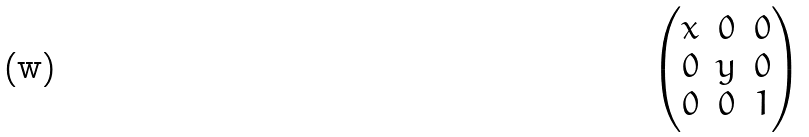<formula> <loc_0><loc_0><loc_500><loc_500>\begin{pmatrix} x & 0 & 0 \\ 0 & y & 0 \\ 0 & 0 & 1 \\ \end{pmatrix}</formula> 